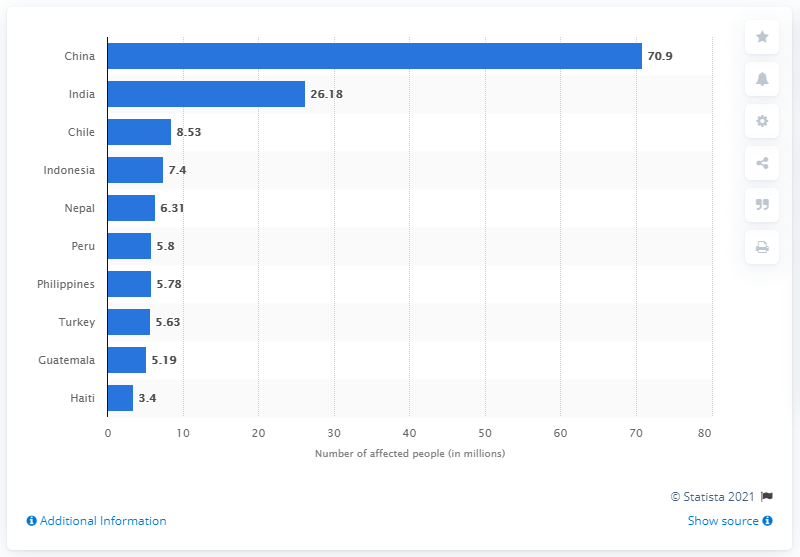How many people in China were affected by earthquakes between 1900 and 2016?
 70.9 